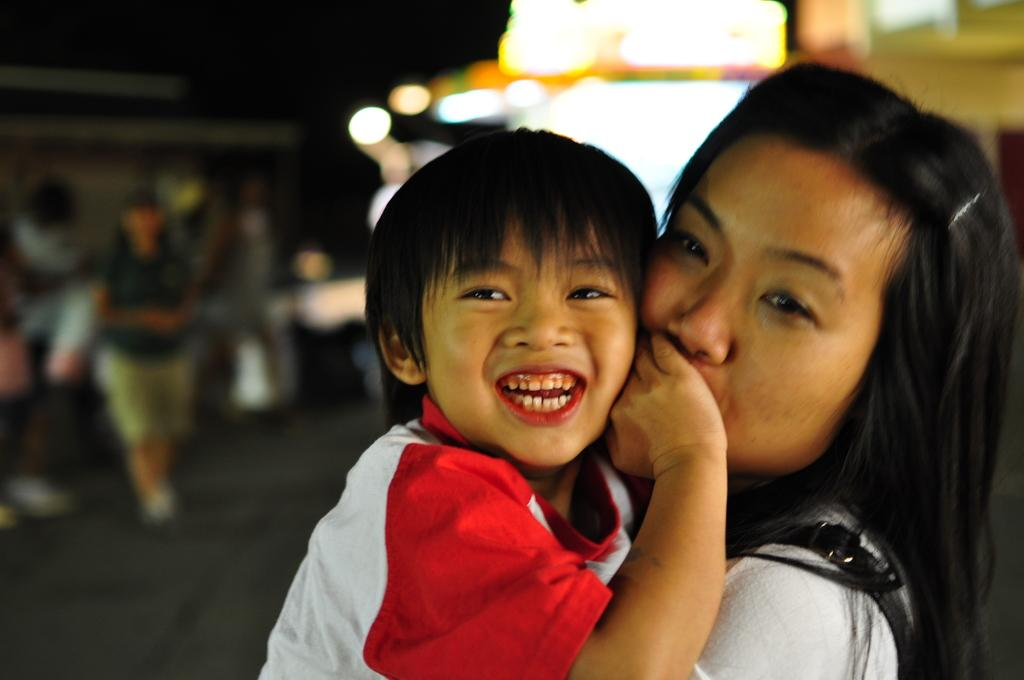Who is the main subject in the image? There is a woman in the image. What is the woman doing in the image? The woman is carrying a kid in her hands. Can you describe the background of the image? There are other objects in the background of the image. What type of iron is the woman using to press her clothes in the image? There is no iron present in the image; the woman is carrying a kid in her hands. Is the woman a self-proclaimed spy in the image? There is no indication in the image that the woman is a spy or has any connection to espionage. 